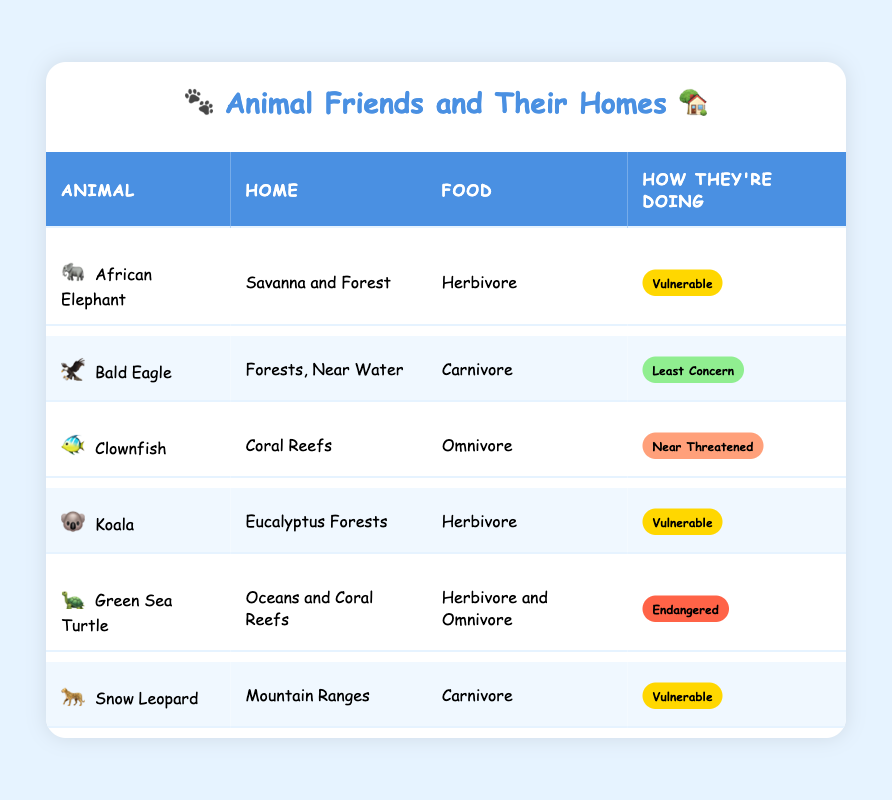What habitat does the African Elephant live in? The table shows that the African Elephant's habitat is listed as "Savanna and Forest". This information is directly referenced from the row containing African Elephant.
Answer: Savanna and Forest Which animals are carnivores? Looking at the "Food" column, the animals identified as carnivores are "Bald Eagle" and "Snow Leopard". I found these by searching for the term "Carnivore" in the table.
Answer: Bald Eagle, Snow Leopard How many animals are listed as vulnerable? The table indicates that three animals are marked as vulnerable: African Elephant, Koala, and Snow Leopard. I counted these directly from the "How They're Doing" column where it is marked as vulnerable.
Answer: 3 Is the Clownfish endangered? The table specifies that the conservation status of the Clownfish is "Near Threatened" and does not indicate that it is endangered. Therefore, the answer is based on the conservation status mentioned.
Answer: No What is the average number of habitats associated with these animals? To find the average habitats, I counted the unique habitats provided in each row: Savanna and Forest, Forests Near Water, Coral Reefs, Eucalyptus Forests, Oceans and Coral Reefs, and Mountain Ranges, totaling 6 unique habitats. Since there are 6 animals, the average is calculated as 6/6 = 1.
Answer: 1 Which animal has the worst conservation status? Looking at the conservation statuses in the "How They’re Doing" column, the animal with the worst status is the Green Sea Turtle, marked as "Endangered". I compared the statuses from all animals and noted that endangered appears lower than vulnerable or least concern.
Answer: Green Sea Turtle How many animals are herbivores and also vulnerable? In the table, the herbivores mentioned are African Elephant and Koala. Both of these are also marked as vulnerable. Thus, I found these by cross-referencing the "Food" and "How They’re Doing" columns.
Answer: 2 Which animal lives in the oceans? The table shows that the "Green Sea Turtle" is the animal listed under the habitat "Oceans and Coral Reefs". This is picked from the habitat information provided in the table.
Answer: Green Sea Turtle 